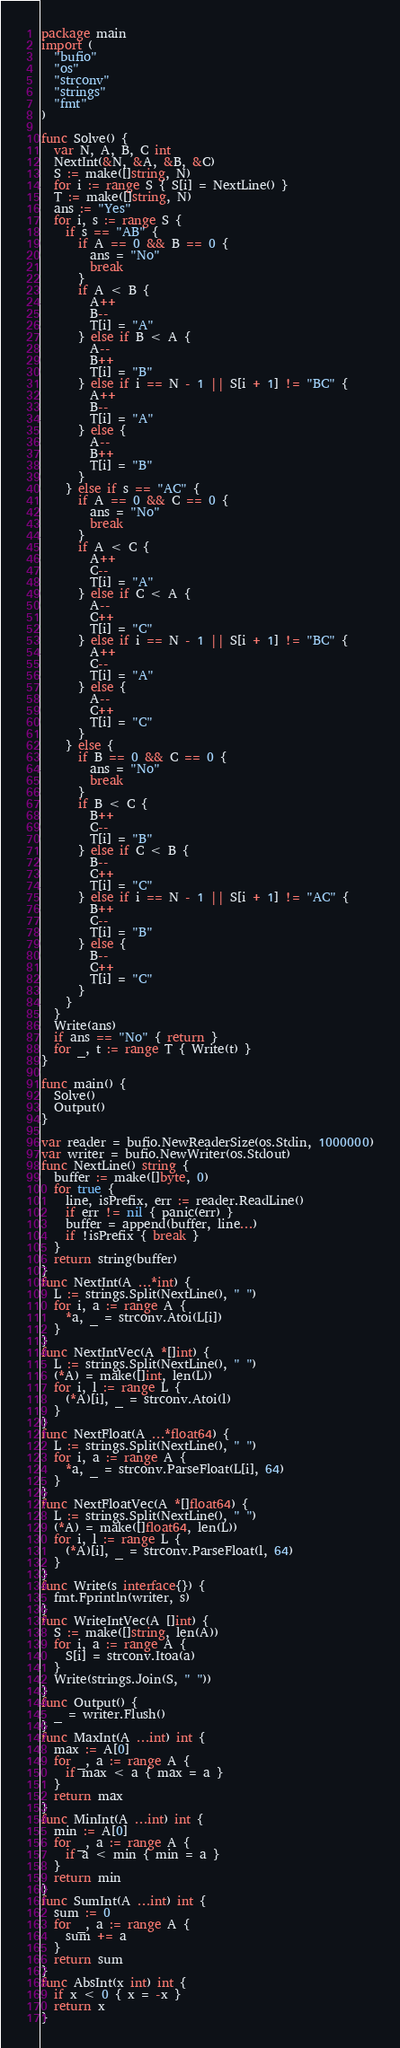Convert code to text. <code><loc_0><loc_0><loc_500><loc_500><_Go_>package main
import (
  "bufio"
  "os"
  "strconv"
  "strings"
  "fmt"
)

func Solve() {
  var N, A, B, C int
  NextInt(&N, &A, &B, &C)
  S := make([]string, N)
  for i := range S { S[i] = NextLine() }
  T := make([]string, N)
  ans := "Yes"
  for i, s := range S {
    if s == "AB" {
      if A == 0 && B == 0 {
        ans = "No"
        break
      }
      if A < B {
        A++
        B--
        T[i] = "A"
      } else if B < A {
        A--
        B++
        T[i] = "B"
      } else if i == N - 1 || S[i + 1] != "BC" {
        A++
        B--
        T[i] = "A"
      } else {
        A--
        B++
        T[i] = "B"
      }
    } else if s == "AC" {
      if A == 0 && C == 0 {
        ans = "No"
        break
      }
      if A < C {
        A++
        C--
        T[i] = "A"
      } else if C < A {
        A--
        C++
        T[i] = "C"
      } else if i == N - 1 || S[i + 1] != "BC" {
        A++
        C--
        T[i] = "A"
      } else {
        A--
        C++
        T[i] = "C"
      }
    } else {
      if B == 0 && C == 0 {
        ans = "No"
        break
      }
      if B < C {
        B++
        C--
        T[i] = "B"
      } else if C < B {
        B--
        C++
        T[i] = "C"
      } else if i == N - 1 || S[i + 1] != "AC" {
        B++
        C--
        T[i] = "B"
      } else {
        B--
        C++
        T[i] = "C"
      }
    }
  }
  Write(ans)
  if ans == "No" { return }
  for _, t := range T { Write(t) }
}

func main() {
  Solve()
  Output()
}

var reader = bufio.NewReaderSize(os.Stdin, 1000000)
var writer = bufio.NewWriter(os.Stdout)
func NextLine() string {
  buffer := make([]byte, 0)
  for true {
    line, isPrefix, err := reader.ReadLine()
    if err != nil { panic(err) }
    buffer = append(buffer, line...)
    if !isPrefix { break }
  }
  return string(buffer)
}
func NextInt(A ...*int) {
  L := strings.Split(NextLine(), " ")
  for i, a := range A {
    *a, _ = strconv.Atoi(L[i])
  }
}
func NextIntVec(A *[]int) {
  L := strings.Split(NextLine(), " ")
  (*A) = make([]int, len(L))
  for i, l := range L {
    (*A)[i], _ = strconv.Atoi(l)
  }
}
func NextFloat(A ...*float64) {
  L := strings.Split(NextLine(), " ")
  for i, a := range A {
    *a, _ = strconv.ParseFloat(L[i], 64)
  }
}
func NextFloatVec(A *[]float64) {
  L := strings.Split(NextLine(), " ")
  (*A) = make([]float64, len(L))
  for i, l := range L {
    (*A)[i], _ = strconv.ParseFloat(l, 64)
  }
}
func Write(s interface{}) {
  fmt.Fprintln(writer, s)
}
func WriteIntVec(A []int) {
  S := make([]string, len(A))
  for i, a := range A {
    S[i] = strconv.Itoa(a)
  }
  Write(strings.Join(S, " "))
}
func Output() {
  _ = writer.Flush()
}
func MaxInt(A ...int) int {
  max := A[0]
  for _, a := range A {
    if max < a { max = a }
  }
  return max
}
func MinInt(A ...int) int {
  min := A[0]
  for _, a := range A {
    if a < min { min = a }
  }
  return min
}
func SumInt(A ...int) int {
  sum := 0
  for _, a := range A {
    sum += a
  }
  return sum
}
func AbsInt(x int) int {
  if x < 0 { x = -x }
  return x
}</code> 